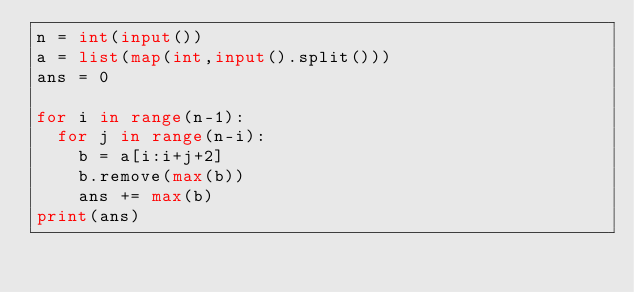<code> <loc_0><loc_0><loc_500><loc_500><_Python_>n = int(input())
a = list(map(int,input().split()))
ans = 0

for i in range(n-1):
  for j in range(n-i):
    b = a[i:i+j+2]
    b.remove(max(b))
    ans += max(b)
print(ans)
    </code> 